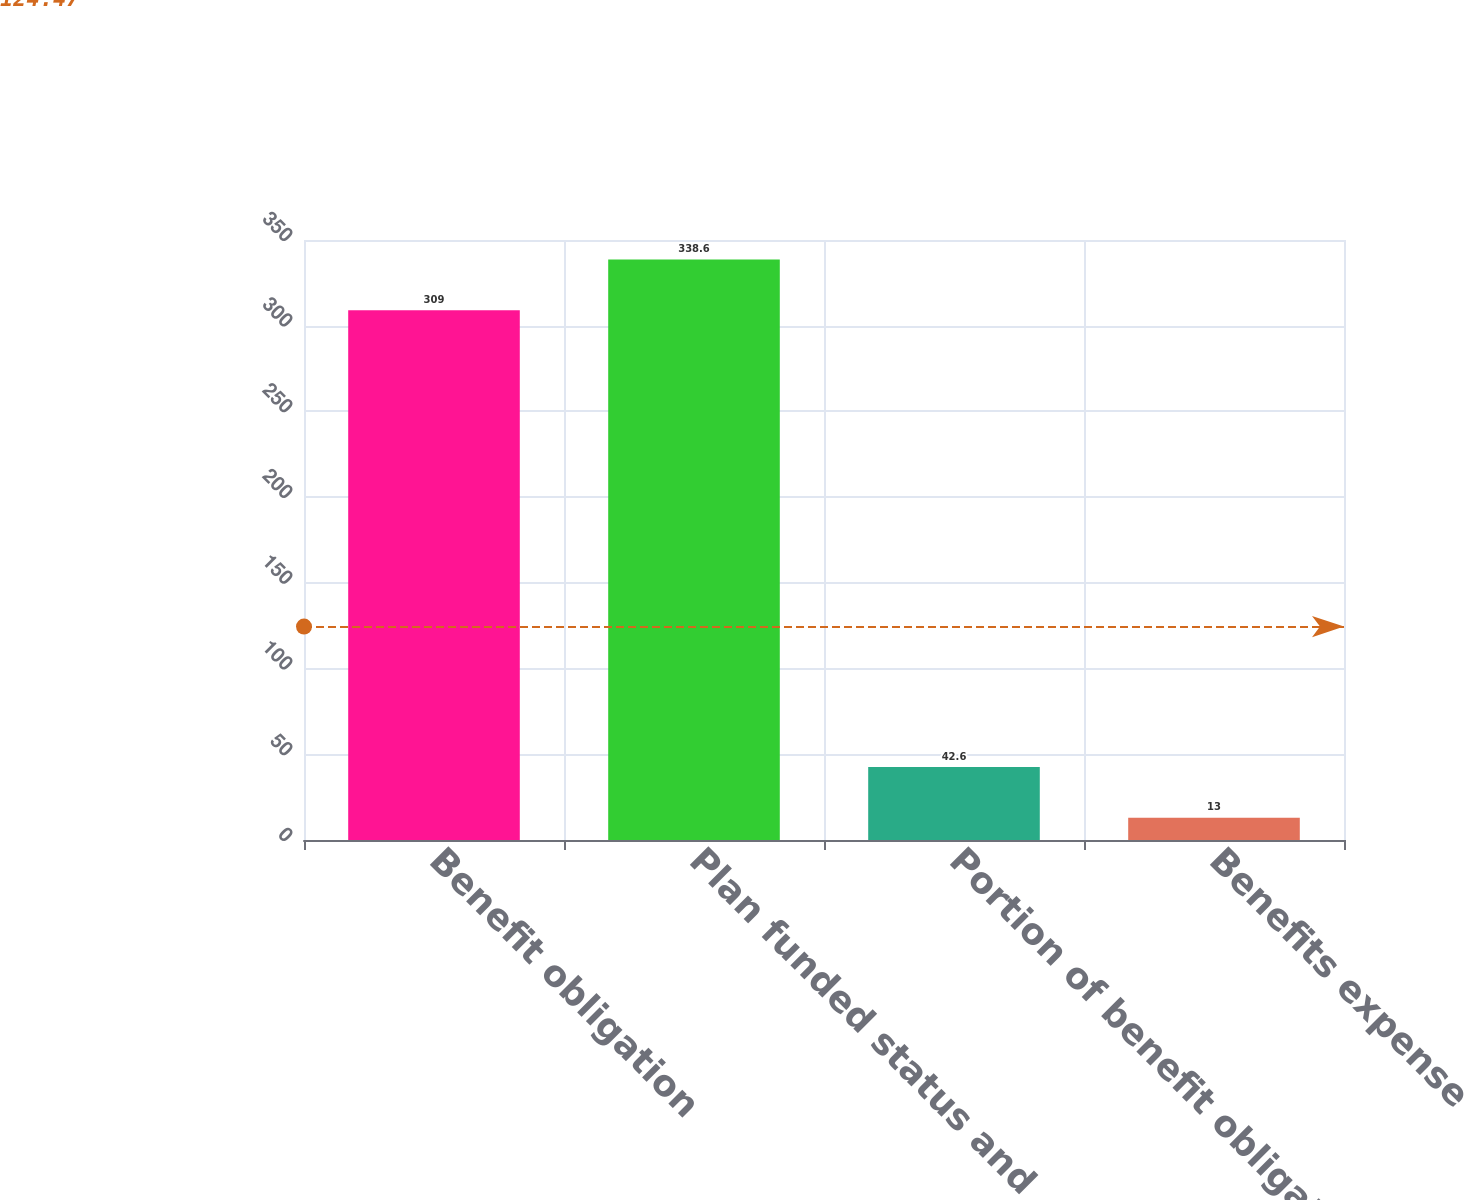Convert chart to OTSL. <chart><loc_0><loc_0><loc_500><loc_500><bar_chart><fcel>Benefit obligation<fcel>Plan funded status and<fcel>Portion of benefit obligation<fcel>Benefits expense<nl><fcel>309<fcel>338.6<fcel>42.6<fcel>13<nl></chart> 